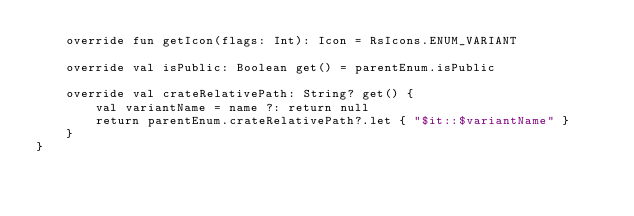Convert code to text. <code><loc_0><loc_0><loc_500><loc_500><_Kotlin_>    override fun getIcon(flags: Int): Icon = RsIcons.ENUM_VARIANT

    override val isPublic: Boolean get() = parentEnum.isPublic

    override val crateRelativePath: String? get() {
        val variantName = name ?: return null
        return parentEnum.crateRelativePath?.let { "$it::$variantName" }
    }
}

</code> 